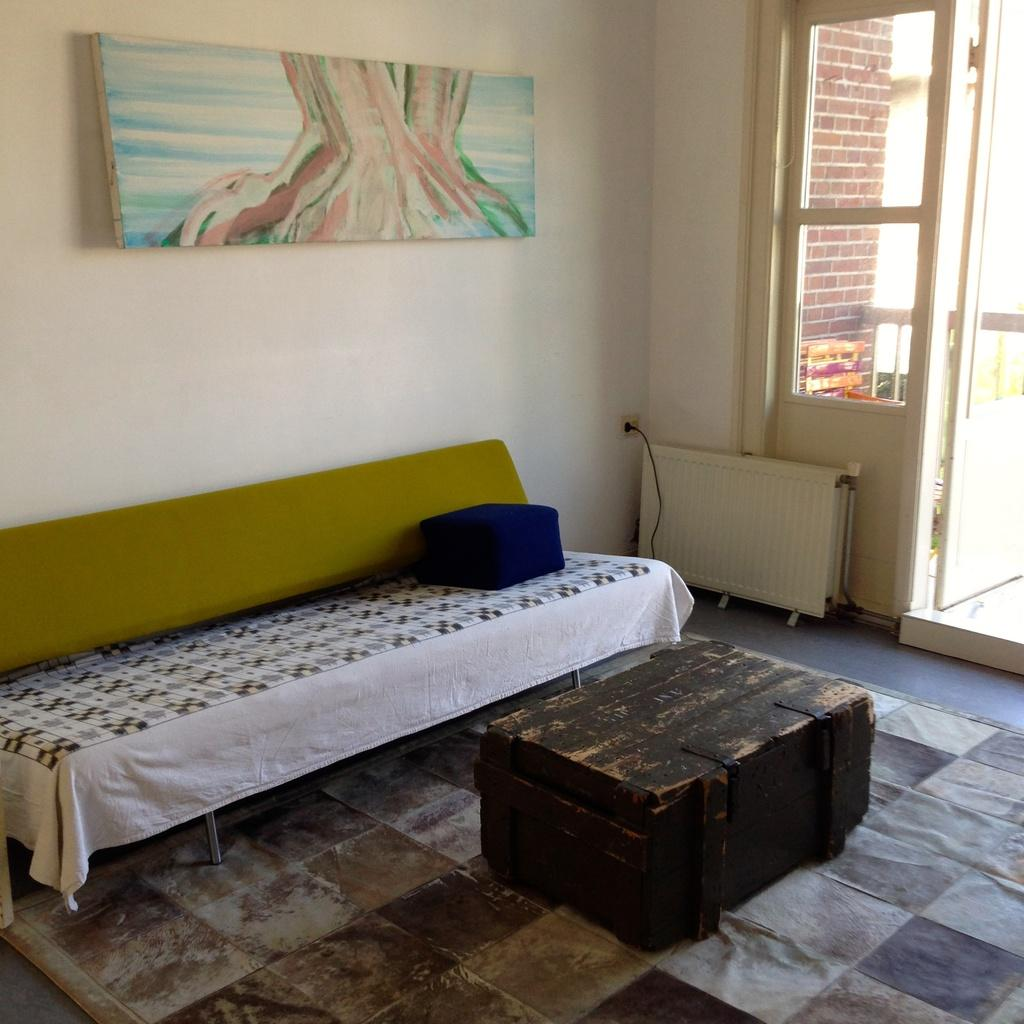What type of furniture is present in the room? There is a bed in the room. What other object can be found in the room? There is a box in the room. Is there any decoration on the wall in the room? Yes, there is a wall with a photo frame in the room. How can one enter or exit the room? There is a door in the room. How many feathers can be seen floating in the air in the room? There are no feathers visible in the image, so it is not possible to determine their presence or quantity. 